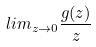<formula> <loc_0><loc_0><loc_500><loc_500>l i m _ { z \rightarrow 0 } \frac { g ( z ) } { z }</formula> 